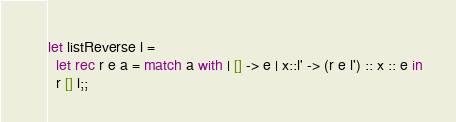<code> <loc_0><loc_0><loc_500><loc_500><_OCaml_>
let listReverse l =
  let rec r e a = match a with | [] -> e | x::l' -> (r e l') :: x :: e in
  r [] l;;
</code> 